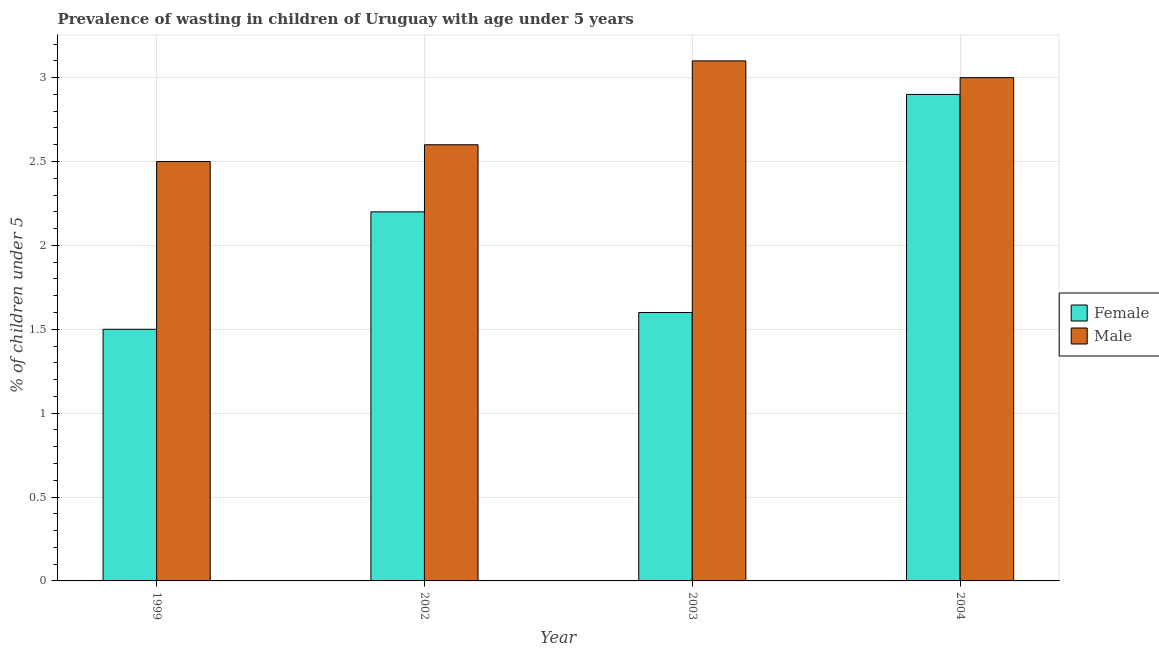How many different coloured bars are there?
Offer a very short reply. 2. Are the number of bars per tick equal to the number of legend labels?
Provide a short and direct response. Yes. How many bars are there on the 4th tick from the left?
Make the answer very short. 2. What is the label of the 1st group of bars from the left?
Your answer should be very brief. 1999. In how many cases, is the number of bars for a given year not equal to the number of legend labels?
Make the answer very short. 0. What is the percentage of undernourished male children in 1999?
Give a very brief answer. 2.5. Across all years, what is the maximum percentage of undernourished female children?
Your response must be concise. 2.9. Across all years, what is the minimum percentage of undernourished male children?
Offer a terse response. 2.5. In which year was the percentage of undernourished male children maximum?
Make the answer very short. 2003. In which year was the percentage of undernourished male children minimum?
Provide a short and direct response. 1999. What is the total percentage of undernourished male children in the graph?
Provide a short and direct response. 11.2. What is the difference between the percentage of undernourished male children in 1999 and that in 2002?
Your answer should be very brief. -0.1. What is the difference between the percentage of undernourished female children in 2003 and the percentage of undernourished male children in 2004?
Keep it short and to the point. -1.3. What is the average percentage of undernourished male children per year?
Ensure brevity in your answer.  2.8. In how many years, is the percentage of undernourished female children greater than 2.3 %?
Your answer should be compact. 1. What is the ratio of the percentage of undernourished female children in 1999 to that in 2002?
Provide a succinct answer. 0.68. What is the difference between the highest and the second highest percentage of undernourished female children?
Your answer should be very brief. 0.7. What is the difference between the highest and the lowest percentage of undernourished male children?
Ensure brevity in your answer.  0.6. In how many years, is the percentage of undernourished female children greater than the average percentage of undernourished female children taken over all years?
Your answer should be compact. 2. Is the sum of the percentage of undernourished male children in 2002 and 2003 greater than the maximum percentage of undernourished female children across all years?
Ensure brevity in your answer.  Yes. How many bars are there?
Provide a succinct answer. 8. How many years are there in the graph?
Your answer should be compact. 4. What is the difference between two consecutive major ticks on the Y-axis?
Your response must be concise. 0.5. Are the values on the major ticks of Y-axis written in scientific E-notation?
Keep it short and to the point. No. Does the graph contain grids?
Your response must be concise. Yes. How many legend labels are there?
Your response must be concise. 2. What is the title of the graph?
Provide a short and direct response. Prevalence of wasting in children of Uruguay with age under 5 years. Does "Canada" appear as one of the legend labels in the graph?
Offer a very short reply. No. What is the label or title of the Y-axis?
Your answer should be compact.  % of children under 5. What is the  % of children under 5 in Female in 1999?
Your response must be concise. 1.5. What is the  % of children under 5 of Male in 1999?
Your answer should be very brief. 2.5. What is the  % of children under 5 in Female in 2002?
Provide a succinct answer. 2.2. What is the  % of children under 5 in Male in 2002?
Make the answer very short. 2.6. What is the  % of children under 5 of Female in 2003?
Offer a terse response. 1.6. What is the  % of children under 5 in Male in 2003?
Ensure brevity in your answer.  3.1. What is the  % of children under 5 in Female in 2004?
Give a very brief answer. 2.9. What is the  % of children under 5 of Male in 2004?
Your answer should be compact. 3. Across all years, what is the maximum  % of children under 5 of Female?
Provide a short and direct response. 2.9. Across all years, what is the maximum  % of children under 5 of Male?
Ensure brevity in your answer.  3.1. Across all years, what is the minimum  % of children under 5 of Female?
Offer a terse response. 1.5. What is the total  % of children under 5 of Female in the graph?
Ensure brevity in your answer.  8.2. What is the total  % of children under 5 of Male in the graph?
Your response must be concise. 11.2. What is the difference between the  % of children under 5 in Male in 1999 and that in 2002?
Make the answer very short. -0.1. What is the difference between the  % of children under 5 of Female in 1999 and that in 2003?
Provide a short and direct response. -0.1. What is the difference between the  % of children under 5 in Male in 1999 and that in 2003?
Offer a terse response. -0.6. What is the difference between the  % of children under 5 of Male in 1999 and that in 2004?
Ensure brevity in your answer.  -0.5. What is the difference between the  % of children under 5 of Female in 2002 and that in 2003?
Your answer should be very brief. 0.6. What is the difference between the  % of children under 5 of Male in 2002 and that in 2003?
Your answer should be very brief. -0.5. What is the difference between the  % of children under 5 in Female in 2002 and that in 2004?
Your response must be concise. -0.7. What is the difference between the  % of children under 5 in Female in 1999 and the  % of children under 5 in Male in 2004?
Keep it short and to the point. -1.5. What is the difference between the  % of children under 5 in Female in 2002 and the  % of children under 5 in Male in 2003?
Your response must be concise. -0.9. What is the difference between the  % of children under 5 of Female in 2002 and the  % of children under 5 of Male in 2004?
Offer a terse response. -0.8. What is the average  % of children under 5 in Female per year?
Ensure brevity in your answer.  2.05. In the year 1999, what is the difference between the  % of children under 5 of Female and  % of children under 5 of Male?
Provide a short and direct response. -1. In the year 2002, what is the difference between the  % of children under 5 of Female and  % of children under 5 of Male?
Offer a very short reply. -0.4. In the year 2003, what is the difference between the  % of children under 5 in Female and  % of children under 5 in Male?
Provide a succinct answer. -1.5. What is the ratio of the  % of children under 5 in Female in 1999 to that in 2002?
Provide a short and direct response. 0.68. What is the ratio of the  % of children under 5 in Male in 1999 to that in 2002?
Your answer should be compact. 0.96. What is the ratio of the  % of children under 5 of Male in 1999 to that in 2003?
Provide a succinct answer. 0.81. What is the ratio of the  % of children under 5 in Female in 1999 to that in 2004?
Your answer should be very brief. 0.52. What is the ratio of the  % of children under 5 in Male in 1999 to that in 2004?
Make the answer very short. 0.83. What is the ratio of the  % of children under 5 in Female in 2002 to that in 2003?
Provide a short and direct response. 1.38. What is the ratio of the  % of children under 5 of Male in 2002 to that in 2003?
Your answer should be compact. 0.84. What is the ratio of the  % of children under 5 of Female in 2002 to that in 2004?
Provide a succinct answer. 0.76. What is the ratio of the  % of children under 5 in Male in 2002 to that in 2004?
Keep it short and to the point. 0.87. What is the ratio of the  % of children under 5 in Female in 2003 to that in 2004?
Provide a short and direct response. 0.55. What is the ratio of the  % of children under 5 of Male in 2003 to that in 2004?
Offer a terse response. 1.03. What is the difference between the highest and the second highest  % of children under 5 in Male?
Offer a very short reply. 0.1. 